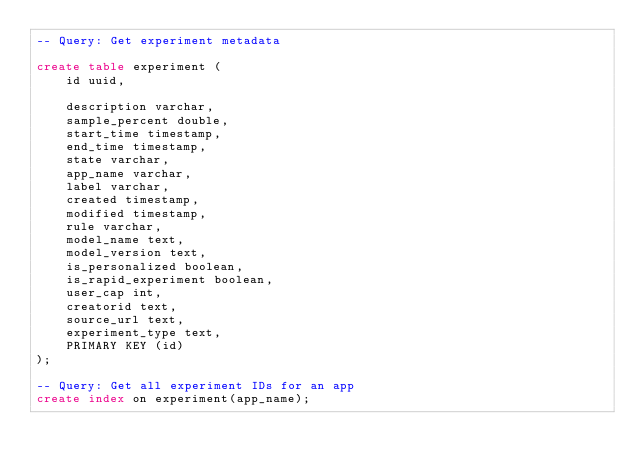<code> <loc_0><loc_0><loc_500><loc_500><_SQL_>-- Query: Get experiment metadata

create table experiment (
    id uuid,

    description varchar,
    sample_percent double,
    start_time timestamp,
    end_time timestamp,
    state varchar,
    app_name varchar,
    label varchar,
    created timestamp,
    modified timestamp,
    rule varchar,
    model_name text,
    model_version text,
    is_personalized boolean,
    is_rapid_experiment boolean,
    user_cap int,
    creatorid text,
    source_url text,
    experiment_type text,
    PRIMARY KEY (id)
);

-- Query: Get all experiment IDs for an app
create index on experiment(app_name);
</code> 